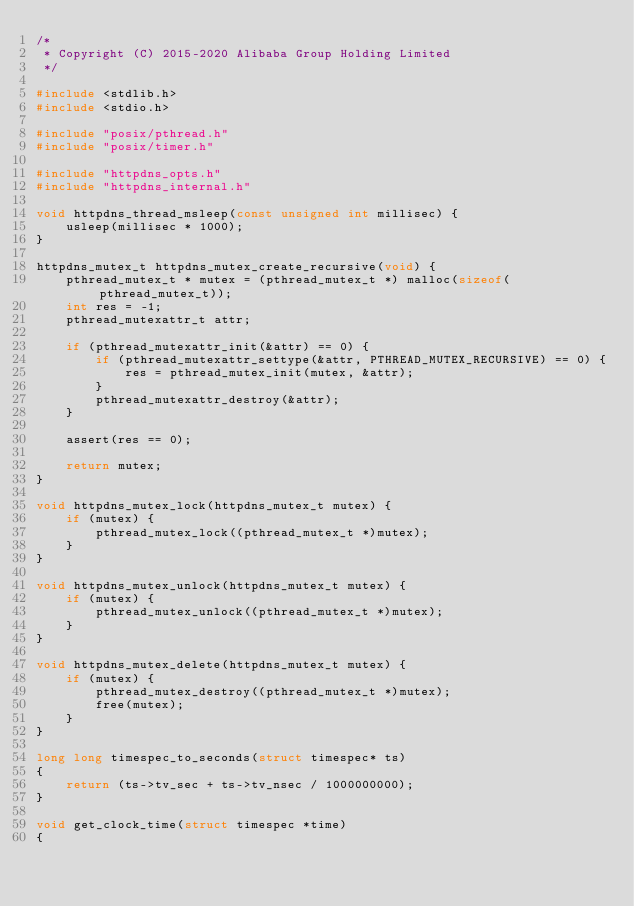<code> <loc_0><loc_0><loc_500><loc_500><_C_>/*
 * Copyright (C) 2015-2020 Alibaba Group Holding Limited
 */

#include <stdlib.h>
#include <stdio.h>

#include "posix/pthread.h"
#include "posix/timer.h"

#include "httpdns_opts.h"
#include "httpdns_internal.h"

void httpdns_thread_msleep(const unsigned int millisec) {
	usleep(millisec * 1000);
}

httpdns_mutex_t httpdns_mutex_create_recursive(void) {
	pthread_mutex_t * mutex = (pthread_mutex_t *) malloc(sizeof(pthread_mutex_t));
	int res = -1;
	pthread_mutexattr_t attr;

	if (pthread_mutexattr_init(&attr) == 0) {
		if (pthread_mutexattr_settype(&attr, PTHREAD_MUTEX_RECURSIVE) == 0) {
			res = pthread_mutex_init(mutex, &attr);
		}
		pthread_mutexattr_destroy(&attr);
	}

	assert(res == 0);

	return mutex;
}

void httpdns_mutex_lock(httpdns_mutex_t mutex) {
	if (mutex) {
		pthread_mutex_lock((pthread_mutex_t *)mutex);
	}
}

void httpdns_mutex_unlock(httpdns_mutex_t mutex) {
	if (mutex) {
		pthread_mutex_unlock((pthread_mutex_t *)mutex);
	}
}

void httpdns_mutex_delete(httpdns_mutex_t mutex) {
	if (mutex) {
		pthread_mutex_destroy((pthread_mutex_t *)mutex);
		free(mutex);
	}
}

long long timespec_to_seconds(struct timespec* ts)
{
    return (ts->tv_sec + ts->tv_nsec / 1000000000);
}

void get_clock_time(struct timespec *time)
{</code> 